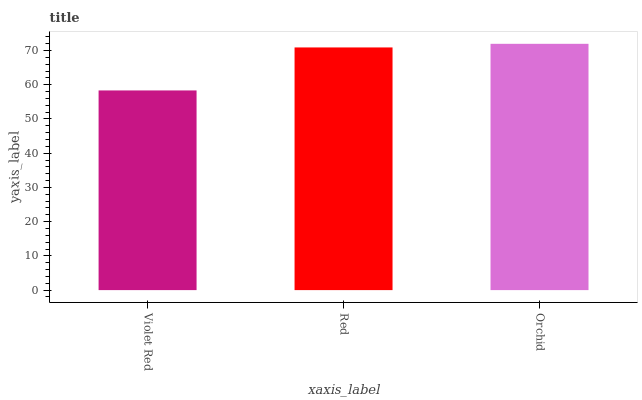Is Violet Red the minimum?
Answer yes or no. Yes. Is Orchid the maximum?
Answer yes or no. Yes. Is Red the minimum?
Answer yes or no. No. Is Red the maximum?
Answer yes or no. No. Is Red greater than Violet Red?
Answer yes or no. Yes. Is Violet Red less than Red?
Answer yes or no. Yes. Is Violet Red greater than Red?
Answer yes or no. No. Is Red less than Violet Red?
Answer yes or no. No. Is Red the high median?
Answer yes or no. Yes. Is Red the low median?
Answer yes or no. Yes. Is Violet Red the high median?
Answer yes or no. No. Is Orchid the low median?
Answer yes or no. No. 